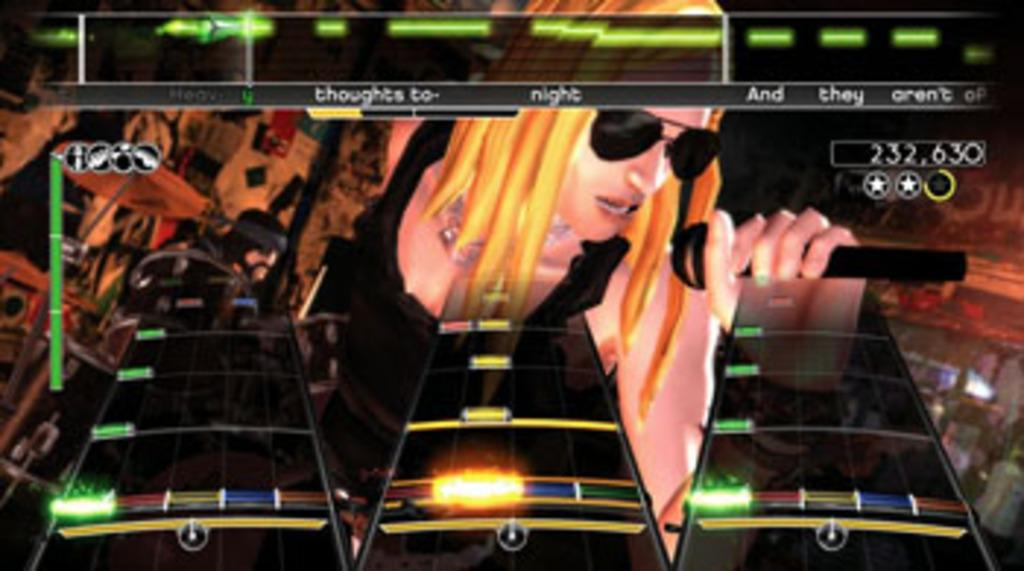What is the main focus of the image? There is a video game screen in the image. Who is present in the image? There is a woman in the image. What is the woman holding in the image? The woman is holding a mic. What can be seen on the woman's face in the image? The woman is wearing spectacles. What type of objects are present in the image, besides the video game screen and the woman? There are three platforms in the image. What is the color of the platforms? The platforms are black in color. What shape is the quarter in the image? There is no quarter present in the image. 